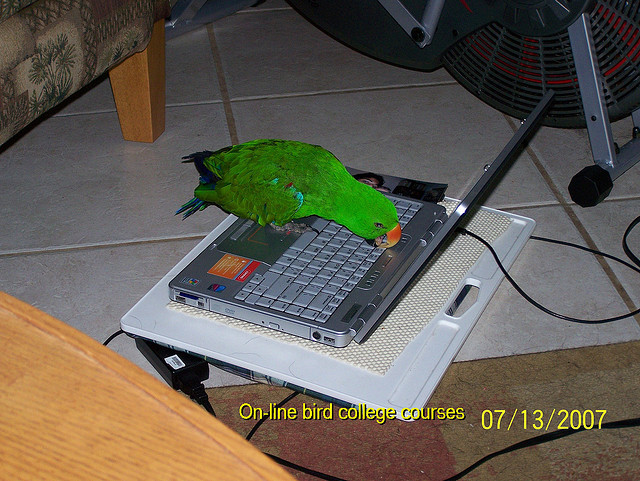<image>What website is the bird looking at? I don't know what website the bird is looking at. It could be an online bird college course, birdscom, or amazoncom. What website is the bird looking at? I don't know what website the bird is looking at. It could be 'online bird college courses', 'birdscom', 'amazoncom', 'on line bird college courses', 'bird college', 'porno', 'college courses', or 'mturk'. 